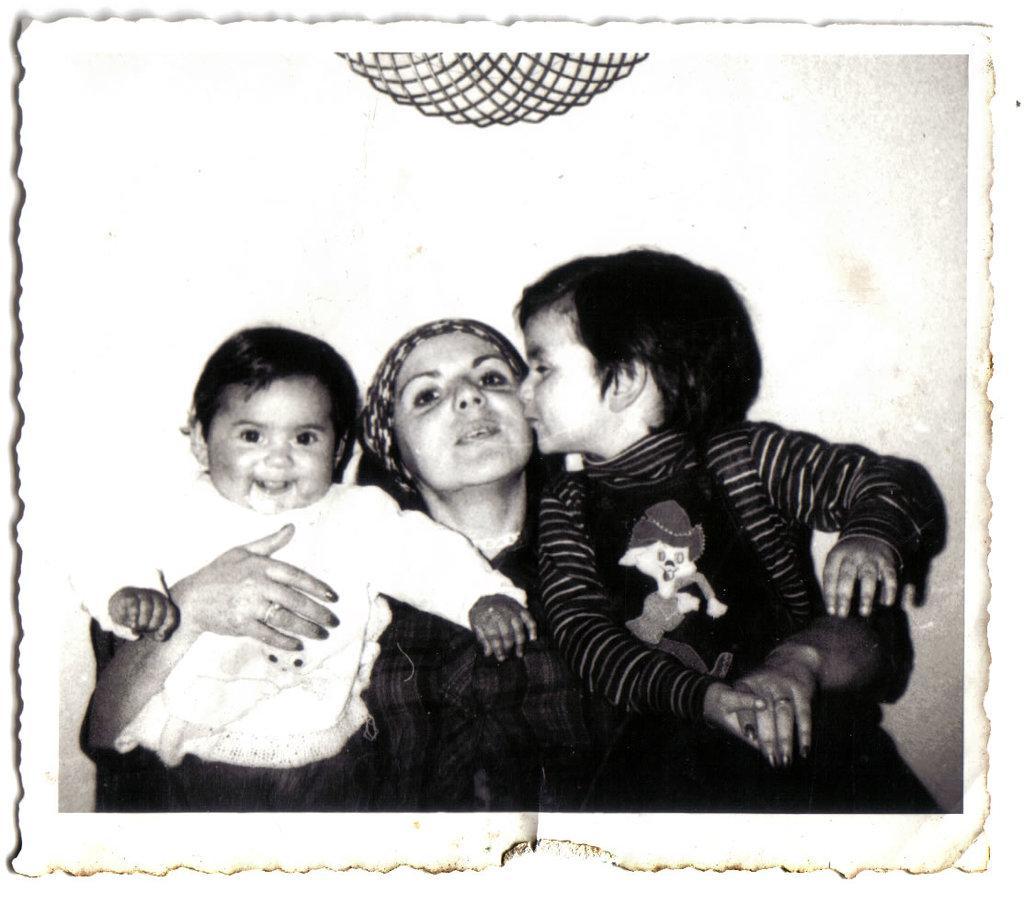Could you give a brief overview of what you see in this image? In this image I can see a woman and I can see she is holding two babies. I can also see this image is black and white in colour. 